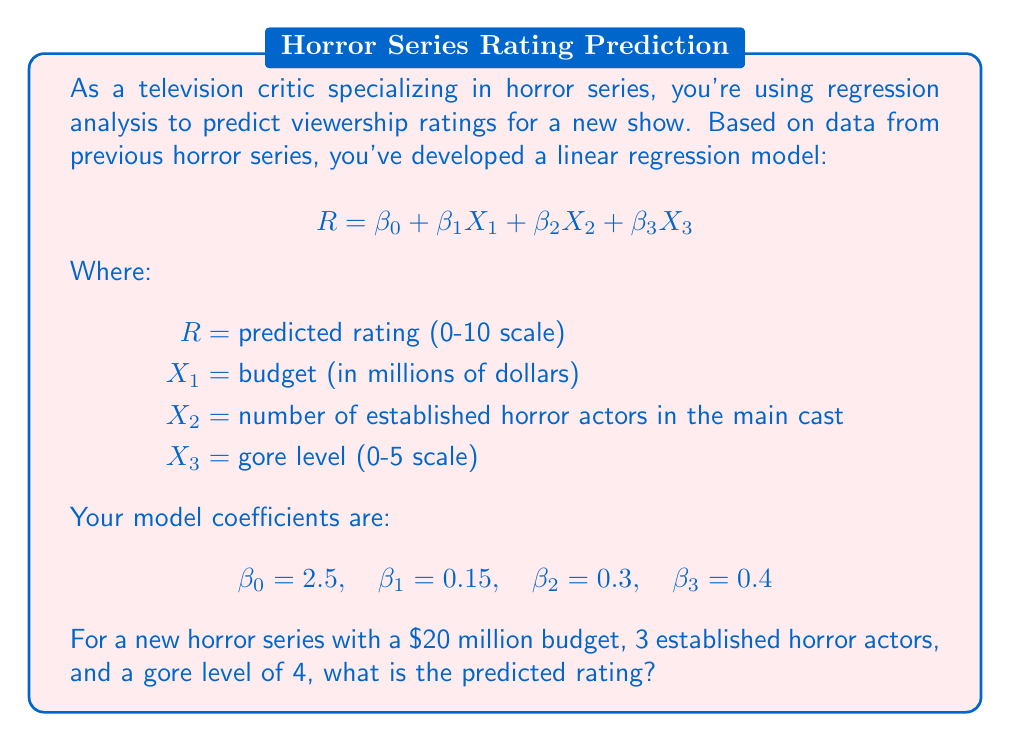Could you help me with this problem? To solve this problem, we'll use the given linear regression equation and substitute the known values:

$$ R = \beta_0 + \beta_1X_1 + \beta_2X_2 + \beta_3X_3 $$

We know:
$\beta_0 = 2.5$
$\beta_1 = 0.15$
$\beta_2 = 0.3$
$\beta_3 = 0.4$

$X_1 = 20$ (budget in millions)
$X_2 = 3$ (number of established horror actors)
$X_3 = 4$ (gore level)

Let's substitute these values into the equation:

$$ R = 2.5 + 0.15(20) + 0.3(3) + 0.4(4) $$

Now, let's calculate each term:
1. $2.5$ (constant term)
2. $0.15 * 20 = 3$ (budget term)
3. $0.3 * 3 = 0.9$ (actors term)
4. $0.4 * 4 = 1.6$ (gore level term)

Adding all these terms:

$$ R = 2.5 + 3 + 0.9 + 1.6 $$

$$ R = 8 $$

Therefore, the predicted rating for the new horror series is 8 out of 10.
Answer: 8 